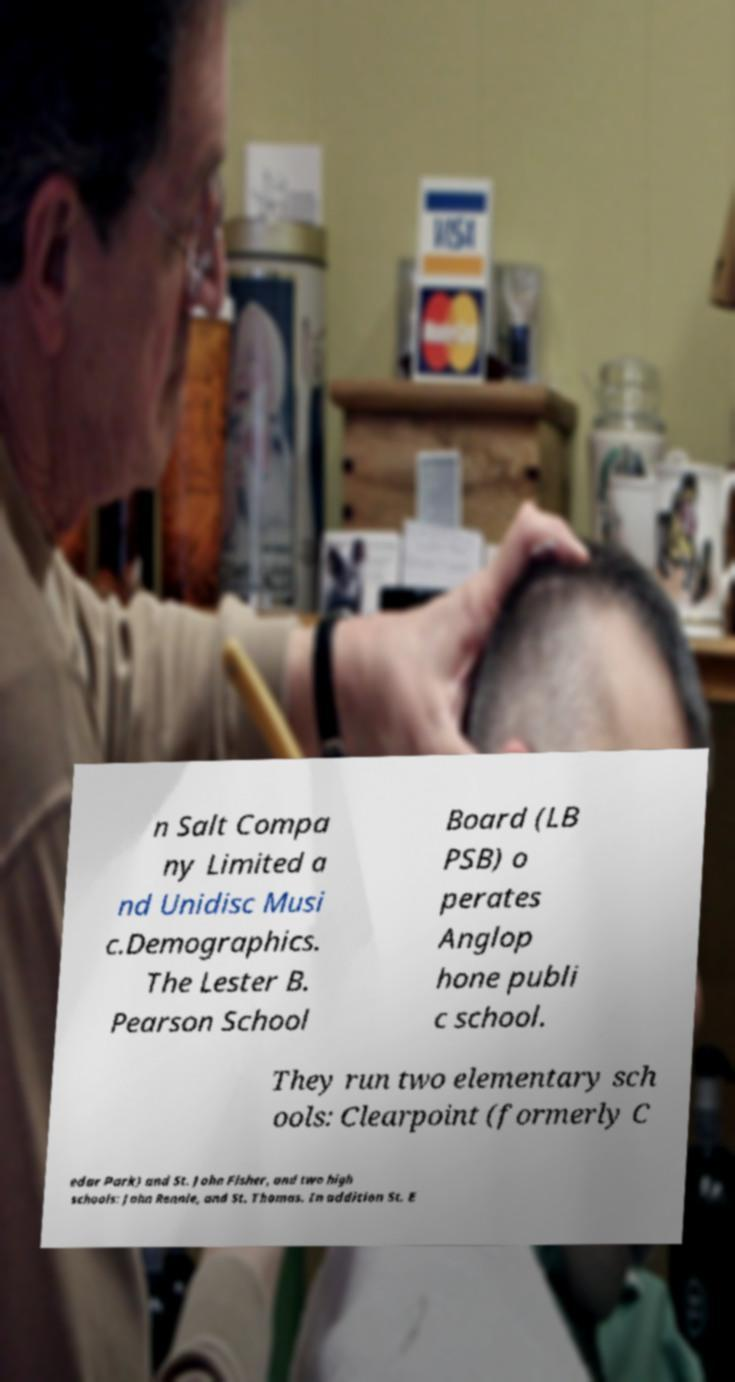Can you read and provide the text displayed in the image?This photo seems to have some interesting text. Can you extract and type it out for me? n Salt Compa ny Limited a nd Unidisc Musi c.Demographics. The Lester B. Pearson School Board (LB PSB) o perates Anglop hone publi c school. They run two elementary sch ools: Clearpoint (formerly C edar Park) and St. John Fisher, and two high schools: John Rennie, and St. Thomas. In addition St. E 